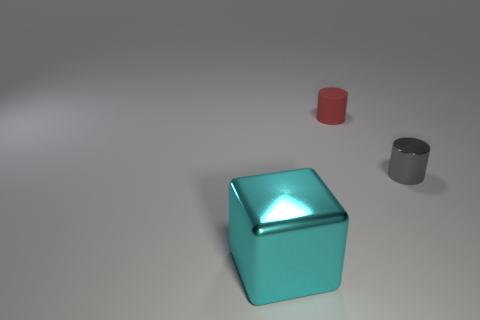Add 2 cyan metallic cubes. How many objects exist? 5 Subtract all blocks. How many objects are left? 2 Subtract all gray cylinders. How many cylinders are left? 1 Subtract all gray blocks. Subtract all brown spheres. How many blocks are left? 1 Subtract all tiny matte objects. Subtract all metal things. How many objects are left? 0 Add 2 red things. How many red things are left? 3 Add 2 blue balls. How many blue balls exist? 2 Subtract 0 gray cubes. How many objects are left? 3 